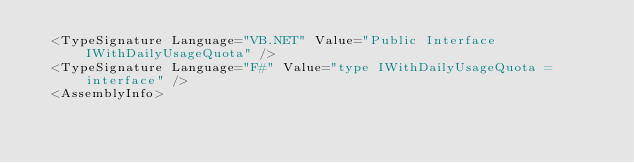Convert code to text. <code><loc_0><loc_0><loc_500><loc_500><_XML_>  <TypeSignature Language="VB.NET" Value="Public Interface IWithDailyUsageQuota" />
  <TypeSignature Language="F#" Value="type IWithDailyUsageQuota = interface" />
  <AssemblyInfo></code> 